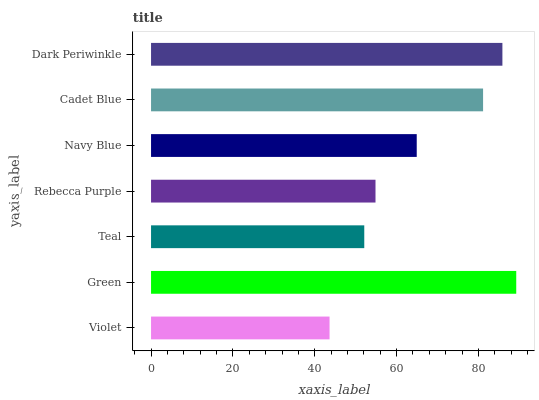Is Violet the minimum?
Answer yes or no. Yes. Is Green the maximum?
Answer yes or no. Yes. Is Teal the minimum?
Answer yes or no. No. Is Teal the maximum?
Answer yes or no. No. Is Green greater than Teal?
Answer yes or no. Yes. Is Teal less than Green?
Answer yes or no. Yes. Is Teal greater than Green?
Answer yes or no. No. Is Green less than Teal?
Answer yes or no. No. Is Navy Blue the high median?
Answer yes or no. Yes. Is Navy Blue the low median?
Answer yes or no. Yes. Is Green the high median?
Answer yes or no. No. Is Dark Periwinkle the low median?
Answer yes or no. No. 